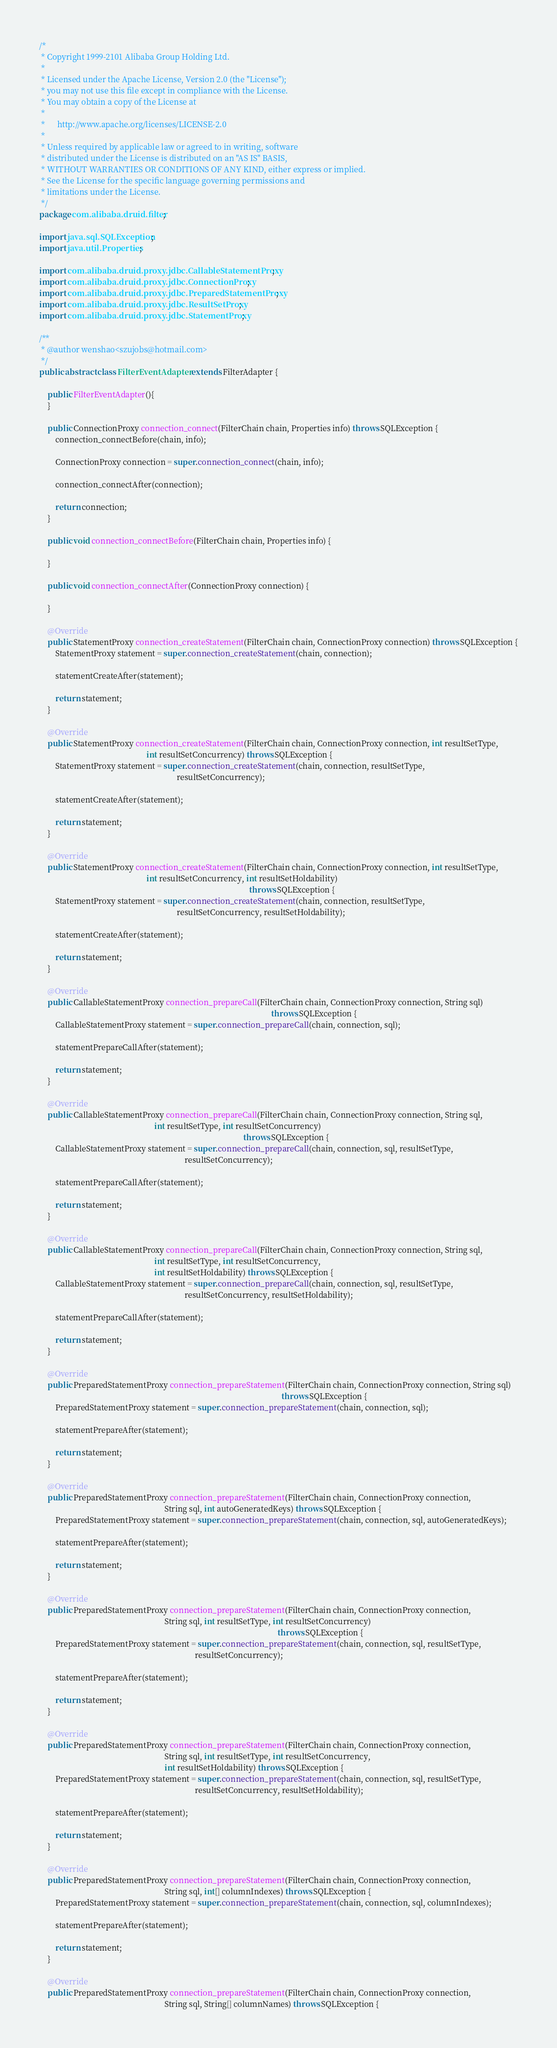<code> <loc_0><loc_0><loc_500><loc_500><_Java_>/*
 * Copyright 1999-2101 Alibaba Group Holding Ltd.
 *
 * Licensed under the Apache License, Version 2.0 (the "License");
 * you may not use this file except in compliance with the License.
 * You may obtain a copy of the License at
 *
 *      http://www.apache.org/licenses/LICENSE-2.0
 *
 * Unless required by applicable law or agreed to in writing, software
 * distributed under the License is distributed on an "AS IS" BASIS,
 * WITHOUT WARRANTIES OR CONDITIONS OF ANY KIND, either express or implied.
 * See the License for the specific language governing permissions and
 * limitations under the License.
 */
package com.alibaba.druid.filter;

import java.sql.SQLException;
import java.util.Properties;

import com.alibaba.druid.proxy.jdbc.CallableStatementProxy;
import com.alibaba.druid.proxy.jdbc.ConnectionProxy;
import com.alibaba.druid.proxy.jdbc.PreparedStatementProxy;
import com.alibaba.druid.proxy.jdbc.ResultSetProxy;
import com.alibaba.druid.proxy.jdbc.StatementProxy;

/**
 * @author wenshao<szujobs@hotmail.com>
 */
public abstract class FilterEventAdapter extends FilterAdapter {

    public FilterEventAdapter(){
    }

    public ConnectionProxy connection_connect(FilterChain chain, Properties info) throws SQLException {
        connection_connectBefore(chain, info);

        ConnectionProxy connection = super.connection_connect(chain, info);

        connection_connectAfter(connection);

        return connection;
    }

    public void connection_connectBefore(FilterChain chain, Properties info) {

    }

    public void connection_connectAfter(ConnectionProxy connection) {

    }

    @Override
    public StatementProxy connection_createStatement(FilterChain chain, ConnectionProxy connection) throws SQLException {
        StatementProxy statement = super.connection_createStatement(chain, connection);

        statementCreateAfter(statement);

        return statement;
    }

    @Override
    public StatementProxy connection_createStatement(FilterChain chain, ConnectionProxy connection, int resultSetType,
                                                     int resultSetConcurrency) throws SQLException {
        StatementProxy statement = super.connection_createStatement(chain, connection, resultSetType,
                                                                    resultSetConcurrency);

        statementCreateAfter(statement);

        return statement;
    }

    @Override
    public StatementProxy connection_createStatement(FilterChain chain, ConnectionProxy connection, int resultSetType,
                                                     int resultSetConcurrency, int resultSetHoldability)
                                                                                                        throws SQLException {
        StatementProxy statement = super.connection_createStatement(chain, connection, resultSetType,
                                                                    resultSetConcurrency, resultSetHoldability);

        statementCreateAfter(statement);

        return statement;
    }

    @Override
    public CallableStatementProxy connection_prepareCall(FilterChain chain, ConnectionProxy connection, String sql)
                                                                                                                   throws SQLException {
        CallableStatementProxy statement = super.connection_prepareCall(chain, connection, sql);

        statementPrepareCallAfter(statement);

        return statement;
    }

    @Override
    public CallableStatementProxy connection_prepareCall(FilterChain chain, ConnectionProxy connection, String sql,
                                                         int resultSetType, int resultSetConcurrency)
                                                                                                     throws SQLException {
        CallableStatementProxy statement = super.connection_prepareCall(chain, connection, sql, resultSetType,
                                                                        resultSetConcurrency);

        statementPrepareCallAfter(statement);

        return statement;
    }

    @Override
    public CallableStatementProxy connection_prepareCall(FilterChain chain, ConnectionProxy connection, String sql,
                                                         int resultSetType, int resultSetConcurrency,
                                                         int resultSetHoldability) throws SQLException {
        CallableStatementProxy statement = super.connection_prepareCall(chain, connection, sql, resultSetType,
                                                                        resultSetConcurrency, resultSetHoldability);

        statementPrepareCallAfter(statement);

        return statement;
    }

    @Override
    public PreparedStatementProxy connection_prepareStatement(FilterChain chain, ConnectionProxy connection, String sql)
                                                                                                                        throws SQLException {
        PreparedStatementProxy statement = super.connection_prepareStatement(chain, connection, sql);

        statementPrepareAfter(statement);

        return statement;
    }

    @Override
    public PreparedStatementProxy connection_prepareStatement(FilterChain chain, ConnectionProxy connection,
                                                              String sql, int autoGeneratedKeys) throws SQLException {
        PreparedStatementProxy statement = super.connection_prepareStatement(chain, connection, sql, autoGeneratedKeys);

        statementPrepareAfter(statement);

        return statement;
    }

    @Override
    public PreparedStatementProxy connection_prepareStatement(FilterChain chain, ConnectionProxy connection,
                                                              String sql, int resultSetType, int resultSetConcurrency)
                                                                                                                      throws SQLException {
        PreparedStatementProxy statement = super.connection_prepareStatement(chain, connection, sql, resultSetType,
                                                                             resultSetConcurrency);

        statementPrepareAfter(statement);

        return statement;
    }

    @Override
    public PreparedStatementProxy connection_prepareStatement(FilterChain chain, ConnectionProxy connection,
                                                              String sql, int resultSetType, int resultSetConcurrency,
                                                              int resultSetHoldability) throws SQLException {
        PreparedStatementProxy statement = super.connection_prepareStatement(chain, connection, sql, resultSetType,
                                                                             resultSetConcurrency, resultSetHoldability);

        statementPrepareAfter(statement);

        return statement;
    }

    @Override
    public PreparedStatementProxy connection_prepareStatement(FilterChain chain, ConnectionProxy connection,
                                                              String sql, int[] columnIndexes) throws SQLException {
        PreparedStatementProxy statement = super.connection_prepareStatement(chain, connection, sql, columnIndexes);

        statementPrepareAfter(statement);

        return statement;
    }

    @Override
    public PreparedStatementProxy connection_prepareStatement(FilterChain chain, ConnectionProxy connection,
                                                              String sql, String[] columnNames) throws SQLException {</code> 